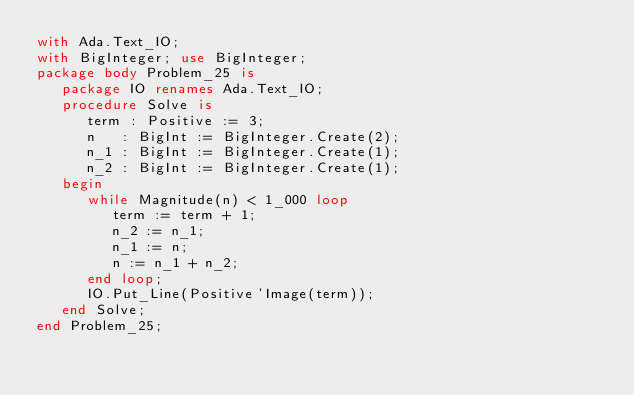Convert code to text. <code><loc_0><loc_0><loc_500><loc_500><_Ada_>with Ada.Text_IO;
with BigInteger; use BigInteger;
package body Problem_25 is
   package IO renames Ada.Text_IO;
   procedure Solve is
      term : Positive := 3;
      n   : BigInt := BigInteger.Create(2);
      n_1 : BigInt := BigInteger.Create(1);
      n_2 : BigInt := BigInteger.Create(1);
   begin
      while Magnitude(n) < 1_000 loop
         term := term + 1;
         n_2 := n_1;
         n_1 := n;
         n := n_1 + n_2;
      end loop;
      IO.Put_Line(Positive'Image(term));
   end Solve;
end Problem_25;
</code> 